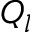<formula> <loc_0><loc_0><loc_500><loc_500>Q _ { l }</formula> 